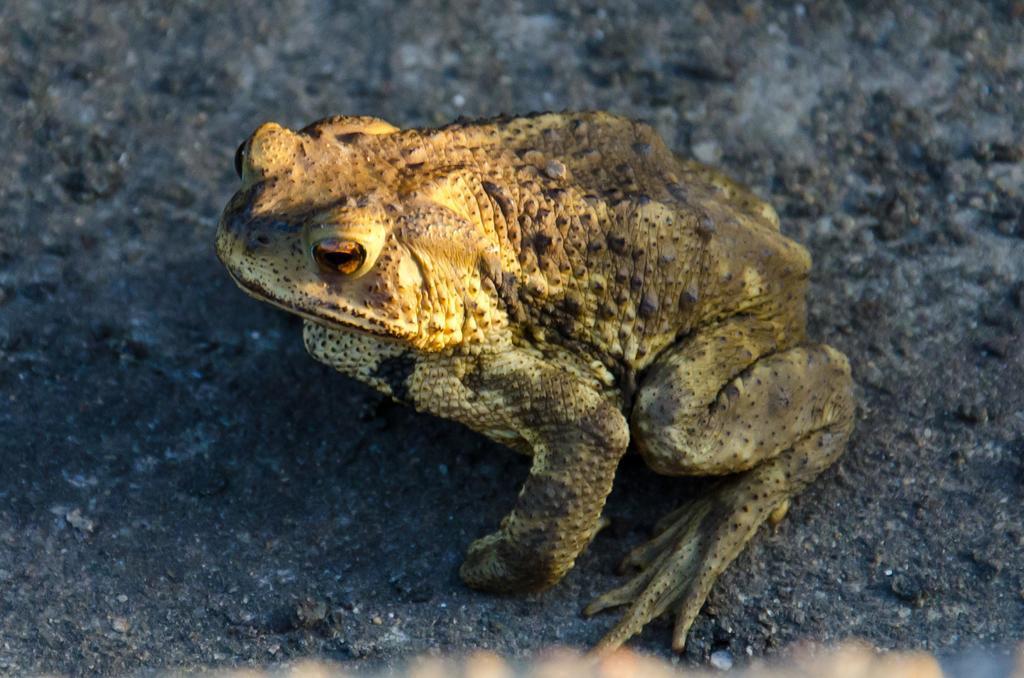How would you summarize this image in a sentence or two? In this image we can see a frog on the ground. 